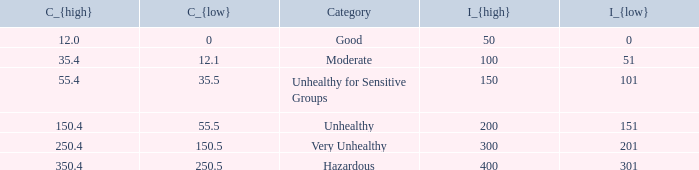I'm looking to parse the entire table for insights. Could you assist me with that? {'header': ['C_{high}', 'C_{low}', 'Category', 'I_{high}', 'I_{low}'], 'rows': [['12.0', '0', 'Good', '50', '0'], ['35.4', '12.1', 'Moderate', '100', '51'], ['55.4', '35.5', 'Unhealthy for Sensitive Groups', '150', '101'], ['150.4', '55.5', 'Unhealthy', '200', '151'], ['250.4', '150.5', 'Very Unhealthy', '300', '201'], ['350.4', '250.5', 'Hazardous', '400', '301']]} In how many different categories is the value of C_{low} 35.5? 1.0. 